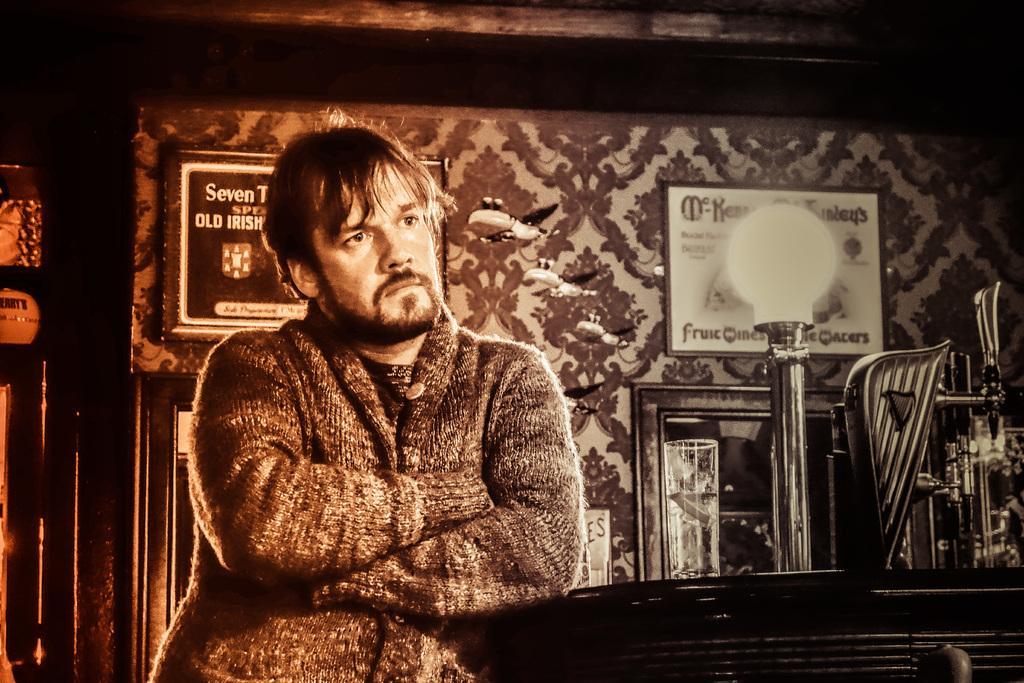In one or two sentences, can you explain what this image depicts? In this picture I can see there is a man standing here and he is looking at right side and there is a table here and a wine glass on it. There is a light and there is a wall in the backdrop and there are photo frames on it. 